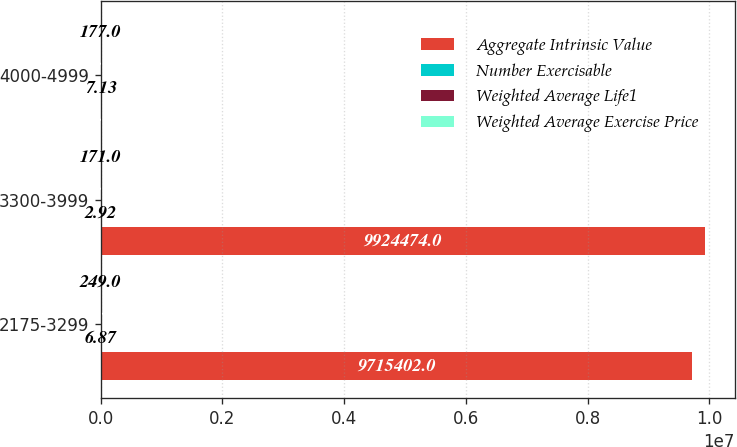Convert chart to OTSL. <chart><loc_0><loc_0><loc_500><loc_500><stacked_bar_chart><ecel><fcel>2175-3299<fcel>3300-3999<fcel>4000-4999<nl><fcel>Aggregate Intrinsic Value<fcel>9.7154e+06<fcel>9.92447e+06<fcel>42.66<nl><fcel>Number Exercisable<fcel>6.87<fcel>2.92<fcel>7.13<nl><fcel>Weighted Average Life1<fcel>27.55<fcel>35.92<fcel>42.66<nl><fcel>Weighted Average Exercise Price<fcel>249<fcel>171<fcel>177<nl></chart> 